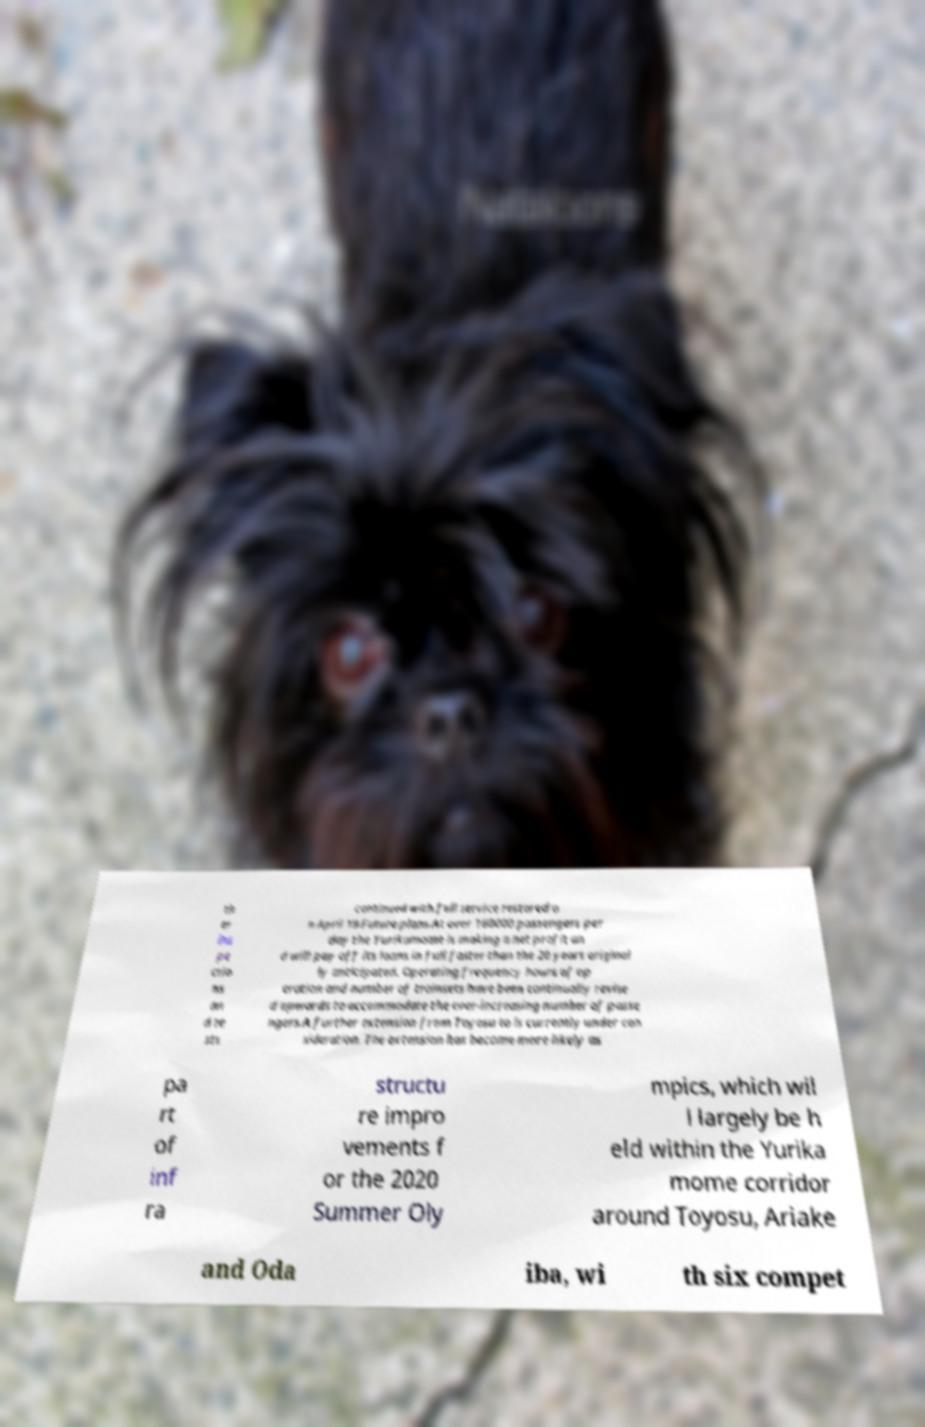Please read and relay the text visible in this image. What does it say? th er ins pe ctio ns an d te sts continued with full service restored o n April 19.Future plans.At over 160000 passengers per day the Yurikamome is making a net profit an d will pay off its loans in full faster than the 20 years original ly anticipated. Operating frequency hours of op eration and number of trainsets have been continually revise d upwards to accommodate the ever-increasing number of passe ngers.A further extension from Toyosu to is currently under con sideration. The extension has become more likely as pa rt of inf ra structu re impro vements f or the 2020 Summer Oly mpics, which wil l largely be h eld within the Yurika mome corridor around Toyosu, Ariake and Oda iba, wi th six compet 